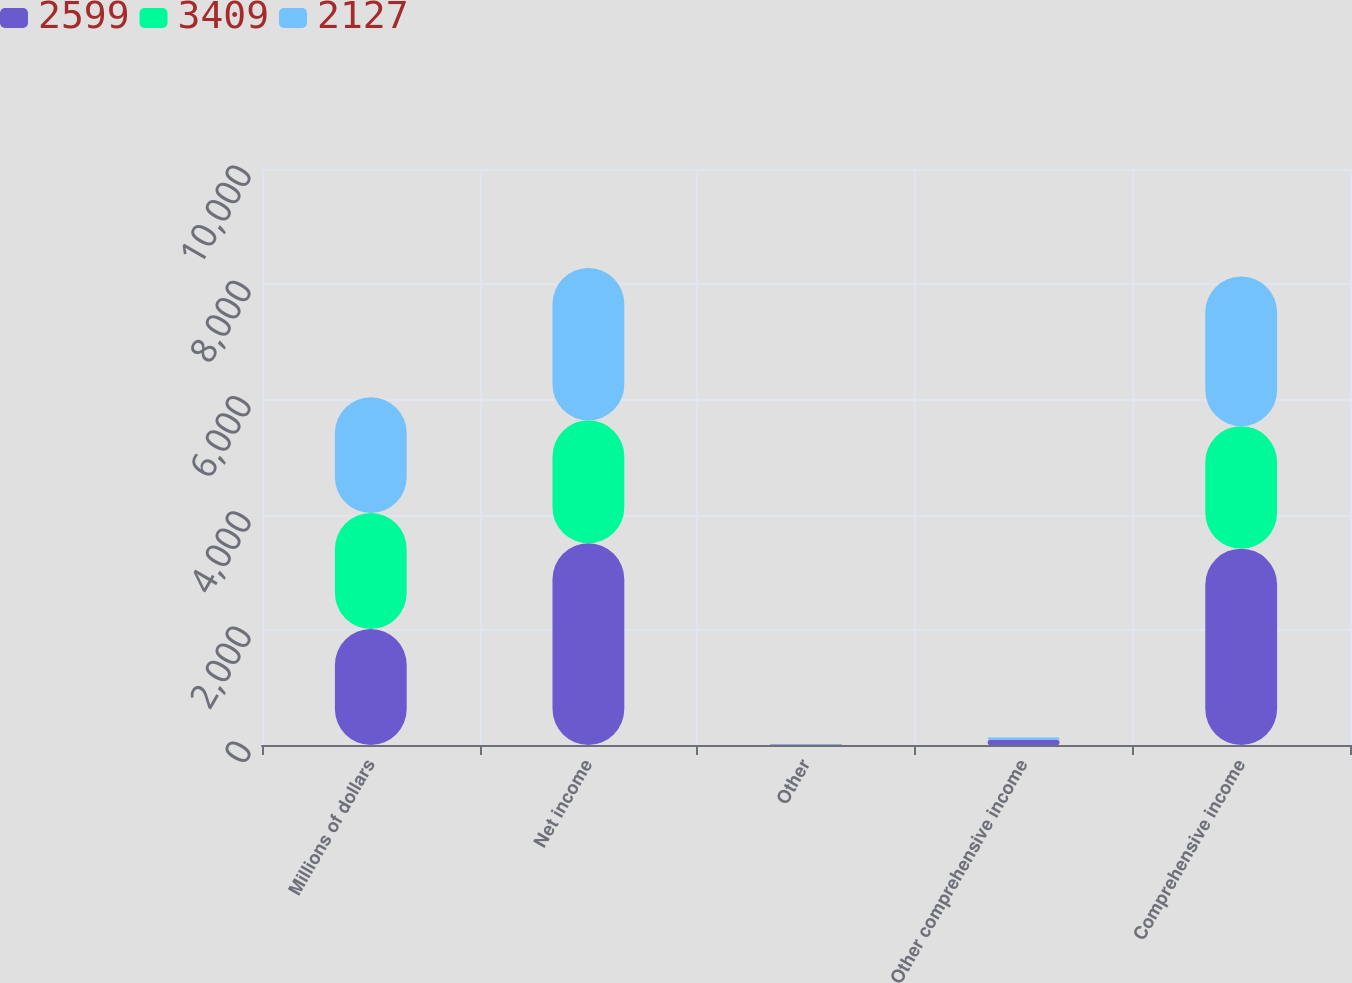Convert chart. <chart><loc_0><loc_0><loc_500><loc_500><stacked_bar_chart><ecel><fcel>Millions of dollars<fcel>Net income<fcel>Other<fcel>Other comprehensive income<fcel>Comprehensive income<nl><fcel>2599<fcel>2014<fcel>3501<fcel>7<fcel>91<fcel>3409<nl><fcel>3409<fcel>2013<fcel>2135<fcel>2<fcel>2<fcel>2127<nl><fcel>2127<fcel>2012<fcel>2645<fcel>3<fcel>36<fcel>2599<nl></chart> 